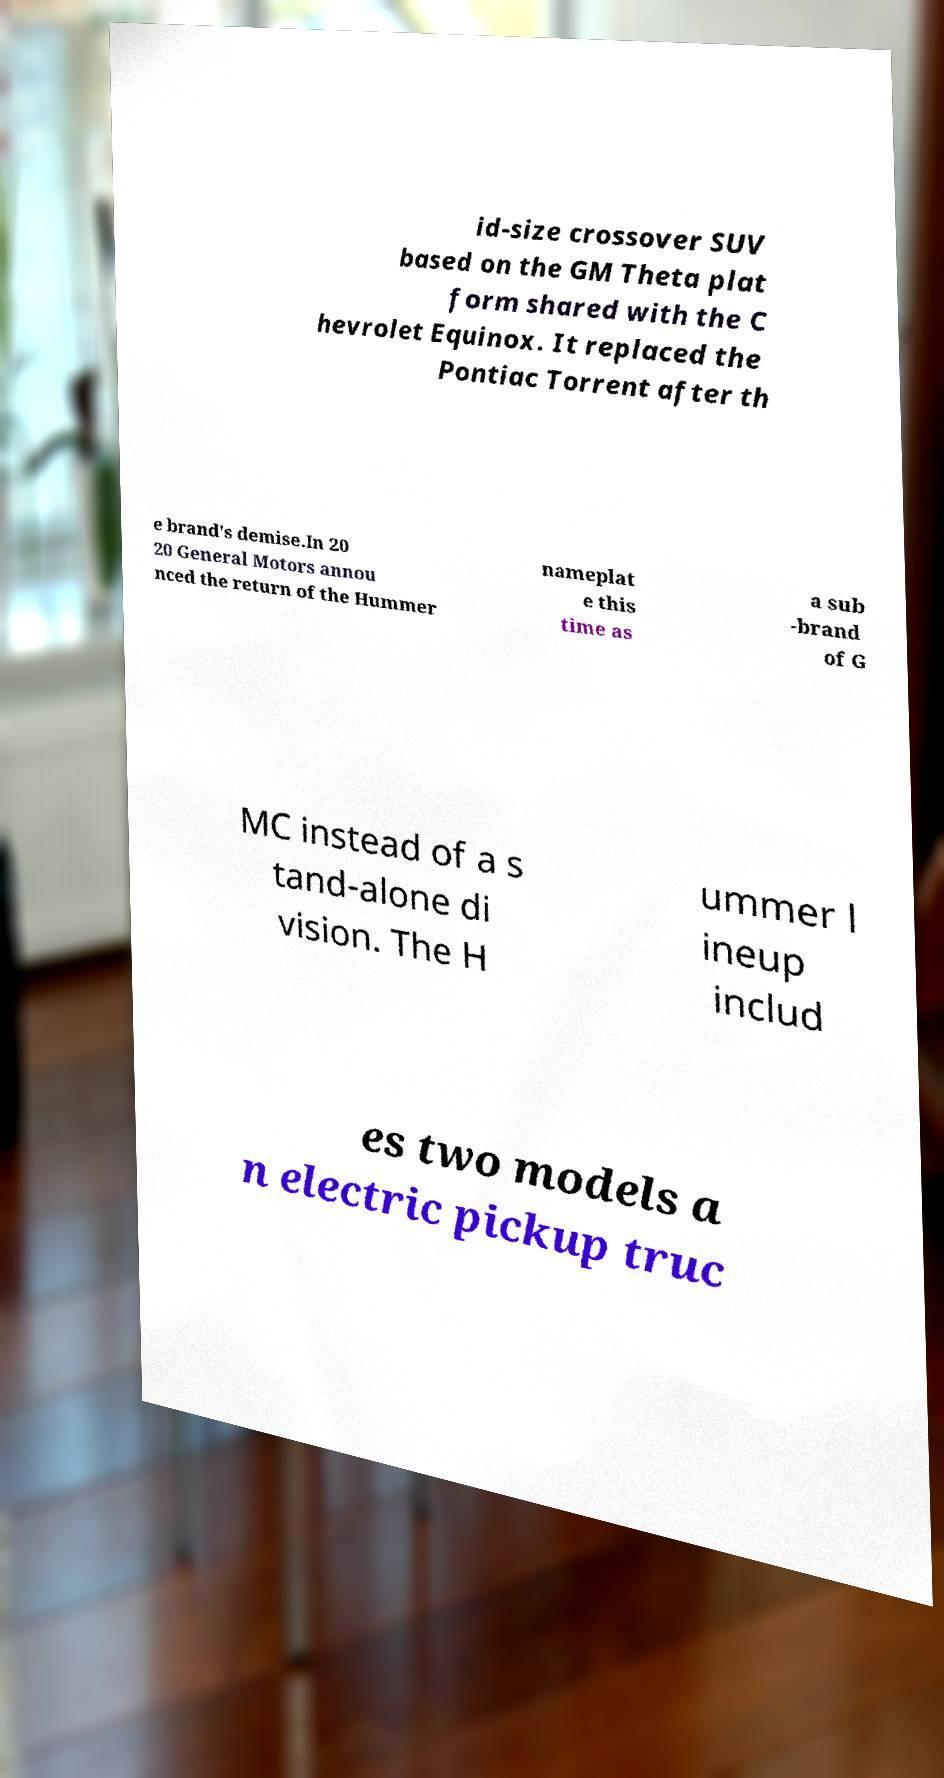Please read and relay the text visible in this image. What does it say? id-size crossover SUV based on the GM Theta plat form shared with the C hevrolet Equinox. It replaced the Pontiac Torrent after th e brand's demise.In 20 20 General Motors annou nced the return of the Hummer nameplat e this time as a sub -brand of G MC instead of a s tand-alone di vision. The H ummer l ineup includ es two models a n electric pickup truc 